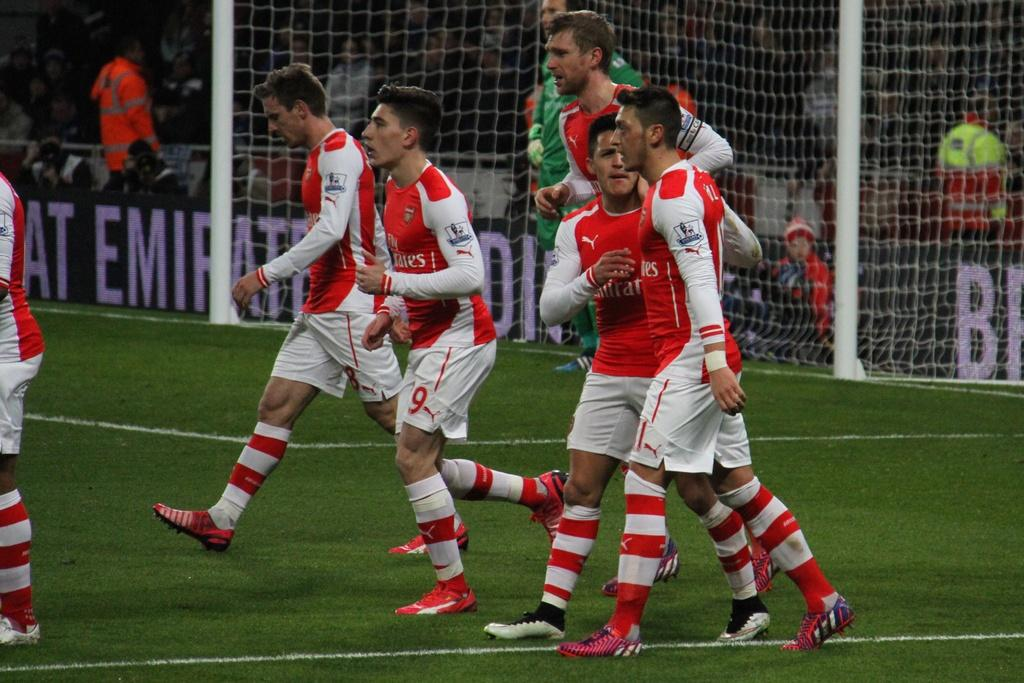<image>
Render a clear and concise summary of the photo. soccer players in red and white wearing united emerates on their jerseys and that is also on sign on stands 